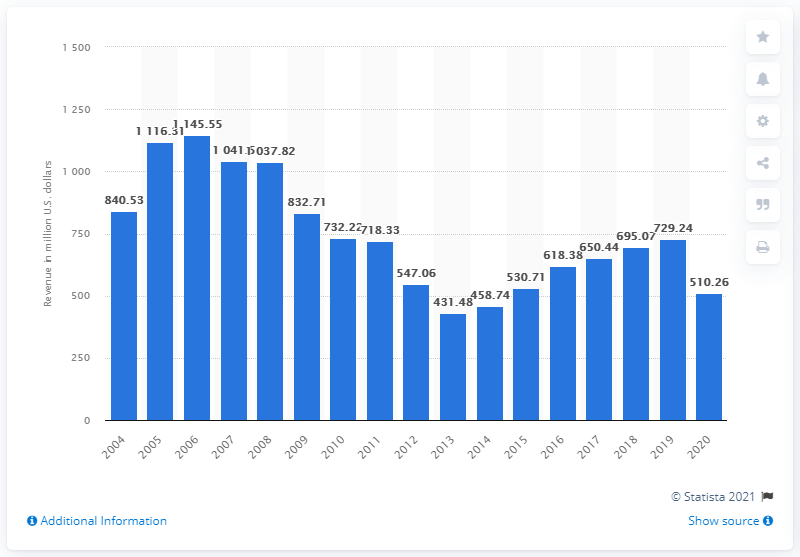Outline some significant characteristics in this image. In 2020, the total revenue of Mesa Airlines was $510.26 million. 